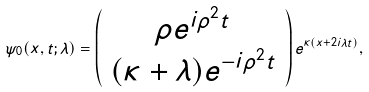Convert formula to latex. <formula><loc_0><loc_0><loc_500><loc_500>\psi _ { 0 } ( x , t ; \lambda ) = \left ( \begin{array} { c } \rho e ^ { i \rho ^ { 2 } t } \\ ( \kappa + \lambda ) e ^ { - i \rho ^ { 2 } t } \end{array} \right ) e ^ { \kappa ( x + 2 i \lambda t ) } ,</formula> 